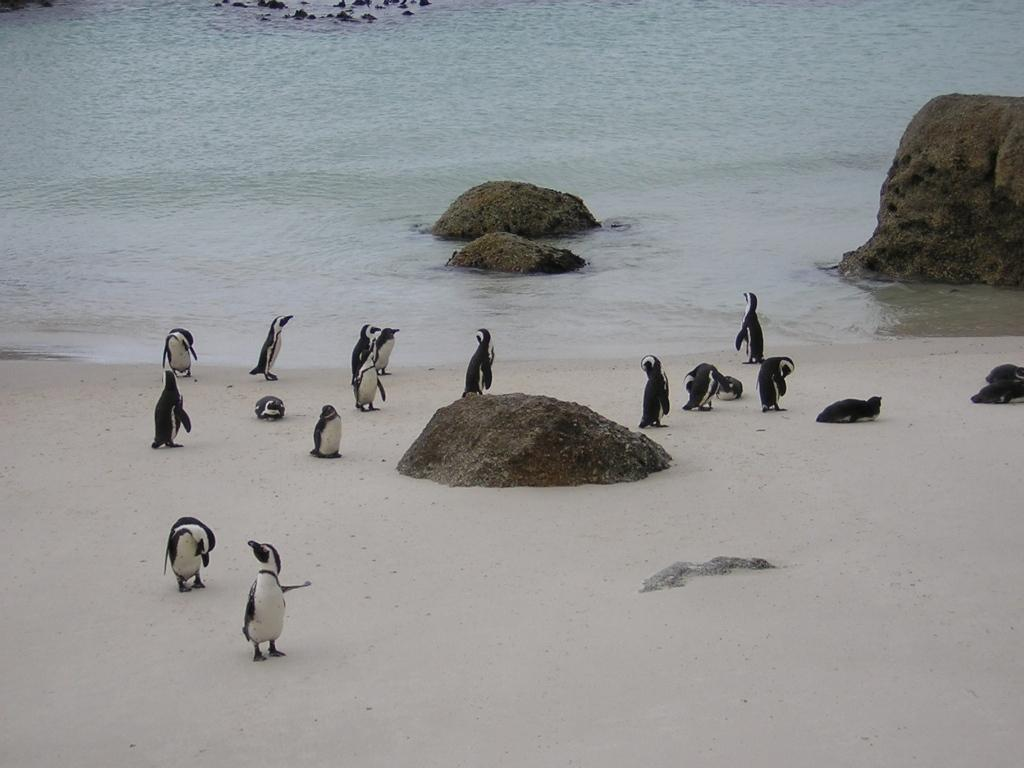What animals are present at the bottom of the image? There are penguins at the bottom of the image. What object can also be found at the bottom of the image? There is a rock at the bottom of the image. What is visible at the top of the image? There is water at the top of the image. What type of objects are present at the top of the image? There are rocks at the top of the image. Can you see the farmer holding a piece of chalk in the image? There is no farmer or chalk present in the image. What type of show is being performed by the penguins in the image? There is no show being performed by the penguins in the image; they are simply standing on the rocks. 